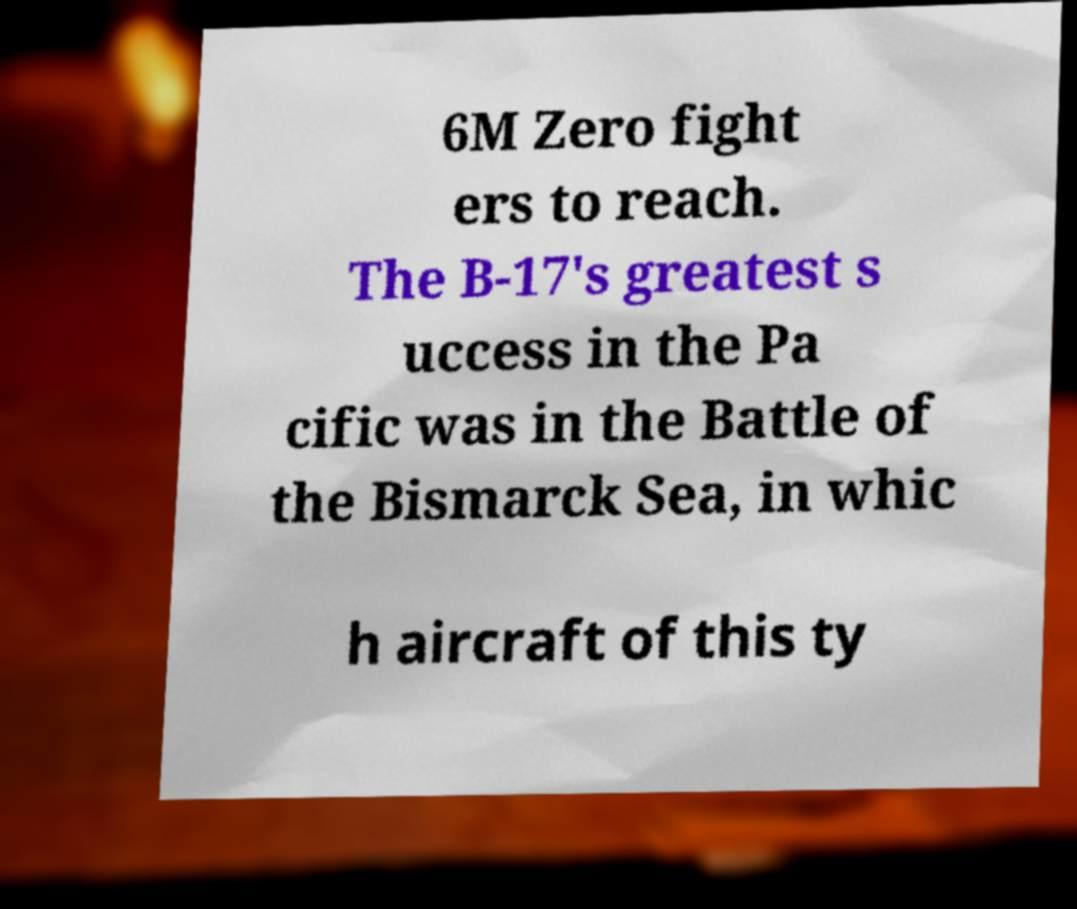Please read and relay the text visible in this image. What does it say? 6M Zero fight ers to reach. The B-17's greatest s uccess in the Pa cific was in the Battle of the Bismarck Sea, in whic h aircraft of this ty 